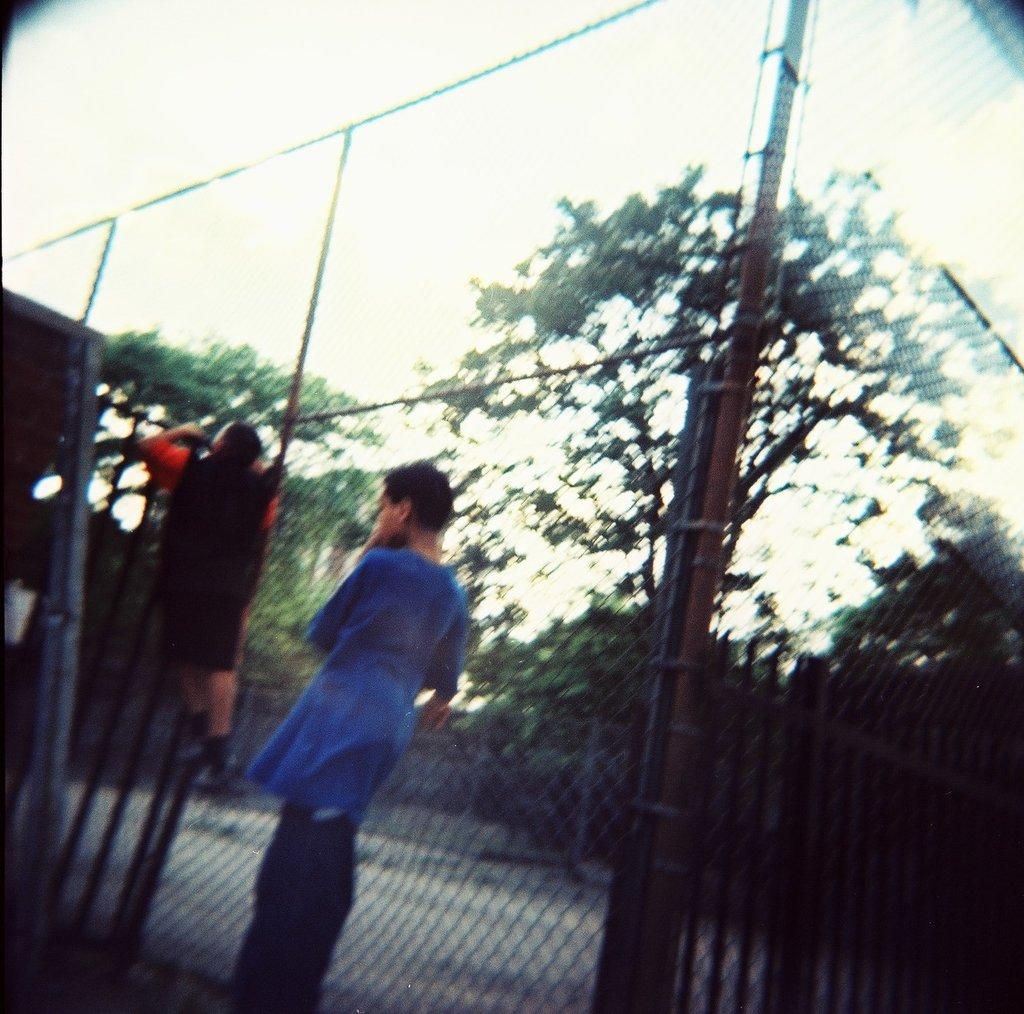What is the main subject of the image? There is a boy standing in the image. What can be seen in the background of the image? Trees are visible in the background of the image. What is the fence made of in the image? The fence is attached to poles in the image. What is the second boy doing in the image? There is another boy climbing the fence in the image. What type of seat can be seen in the image? There is no seat present in the image. What game are the boys playing in the image? There is no game being played in the image; the boys are simply standing and climbing the fence. 